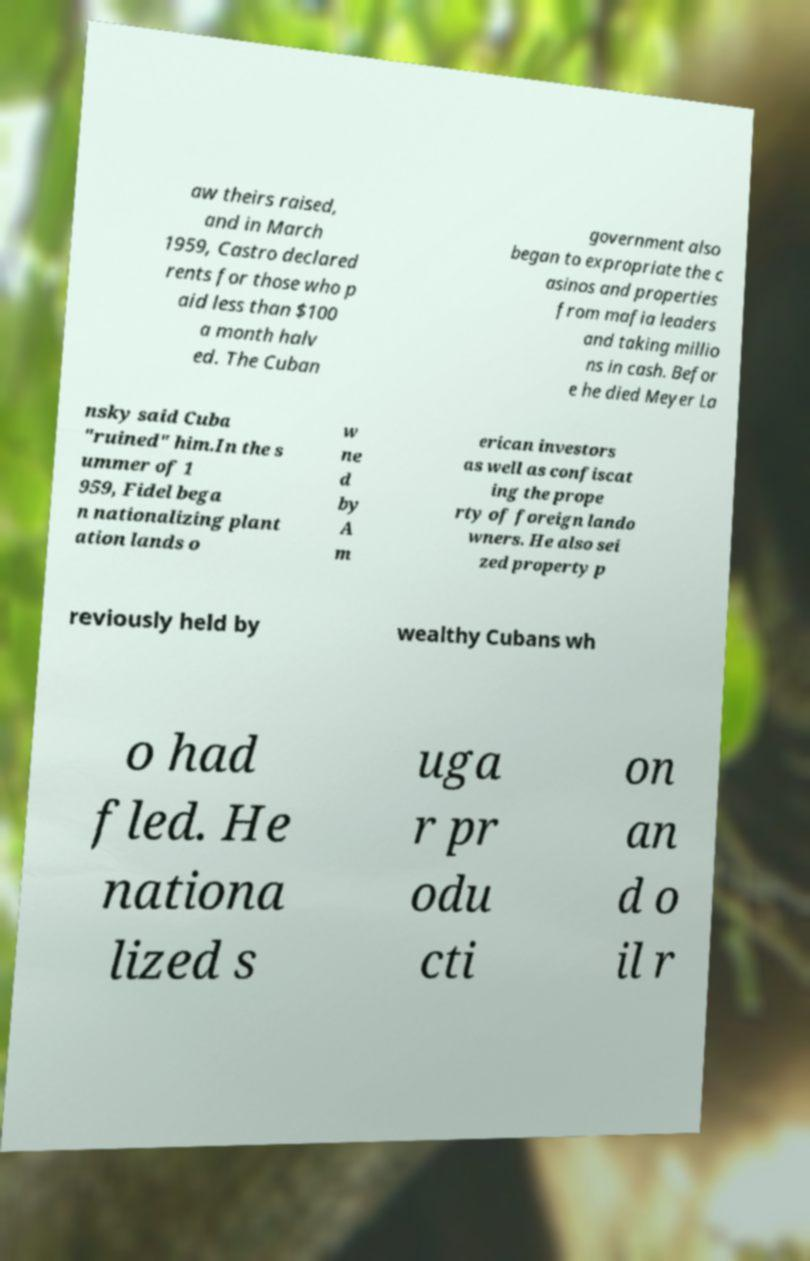Could you assist in decoding the text presented in this image and type it out clearly? aw theirs raised, and in March 1959, Castro declared rents for those who p aid less than $100 a month halv ed. The Cuban government also began to expropriate the c asinos and properties from mafia leaders and taking millio ns in cash. Befor e he died Meyer La nsky said Cuba "ruined" him.In the s ummer of 1 959, Fidel bega n nationalizing plant ation lands o w ne d by A m erican investors as well as confiscat ing the prope rty of foreign lando wners. He also sei zed property p reviously held by wealthy Cubans wh o had fled. He nationa lized s uga r pr odu cti on an d o il r 